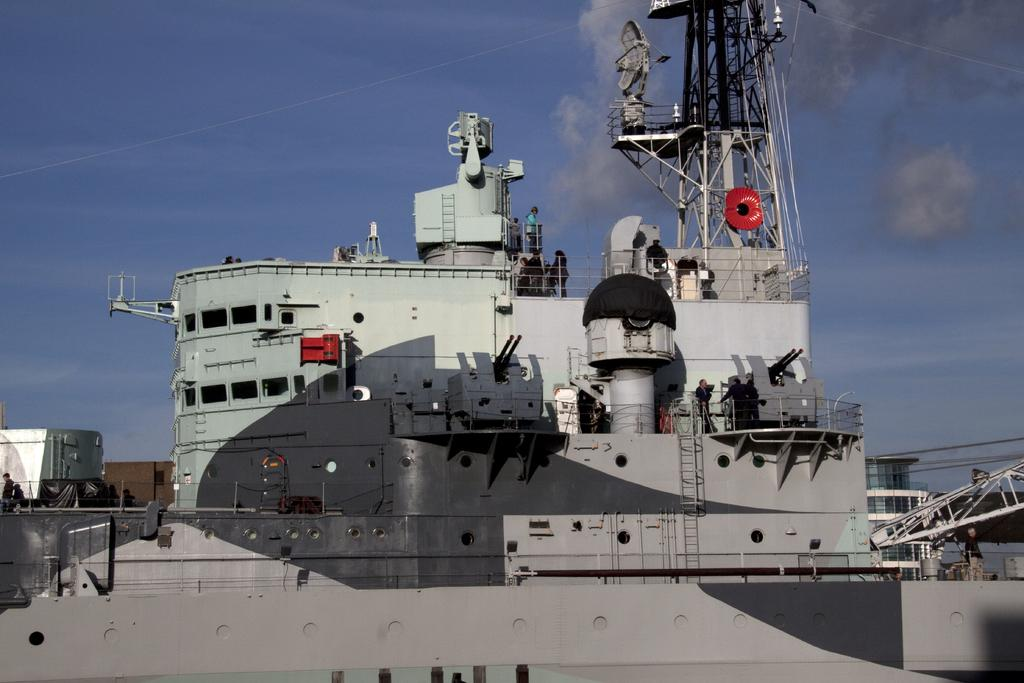What is the main subject of the image? The main subject of the image is a ship. Are there any people on the ship? Yes, there are people on the ship. What can be seen in the background of the image? The sky is visible in the background of the image. What features are present on the ship? There are ladders and a tower on the ship. What type of doll can be seen playing with a pen on the ship in the image? There is no doll or pen present on the ship in the image. 